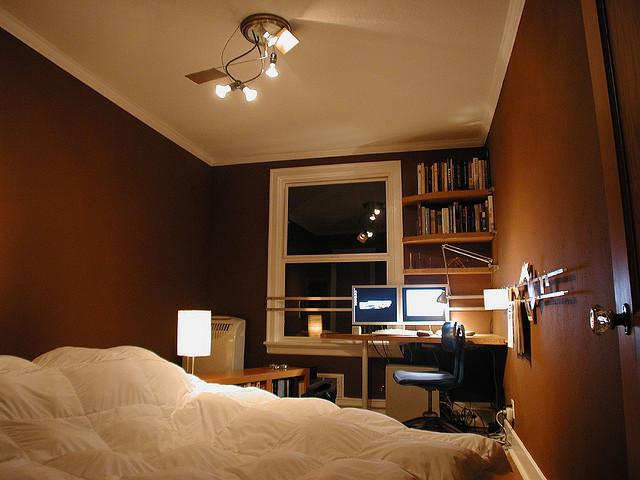What color is the wall?
Write a very short answer. Brown. How many bookshelves are there?
Keep it brief. 3. Is the light in the room on?
Give a very brief answer. Yes. 